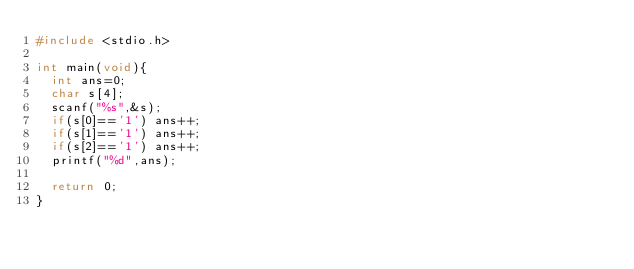<code> <loc_0><loc_0><loc_500><loc_500><_C_>#include <stdio.h>

int main(void){
	int ans=0;
	char s[4];
	scanf("%s",&s);
	if(s[0]=='1') ans++;
	if(s[1]=='1') ans++;
	if(s[2]=='1') ans++;
	printf("%d",ans);
	
	return 0;
}</code> 